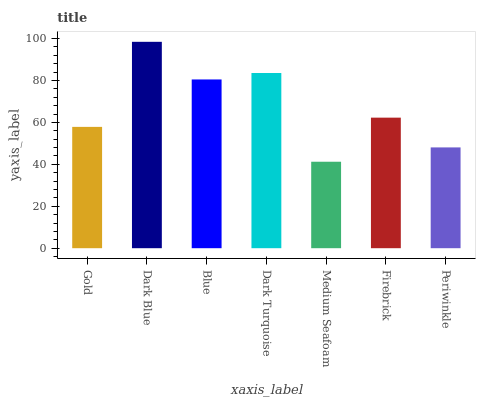Is Medium Seafoam the minimum?
Answer yes or no. Yes. Is Dark Blue the maximum?
Answer yes or no. Yes. Is Blue the minimum?
Answer yes or no. No. Is Blue the maximum?
Answer yes or no. No. Is Dark Blue greater than Blue?
Answer yes or no. Yes. Is Blue less than Dark Blue?
Answer yes or no. Yes. Is Blue greater than Dark Blue?
Answer yes or no. No. Is Dark Blue less than Blue?
Answer yes or no. No. Is Firebrick the high median?
Answer yes or no. Yes. Is Firebrick the low median?
Answer yes or no. Yes. Is Dark Blue the high median?
Answer yes or no. No. Is Periwinkle the low median?
Answer yes or no. No. 